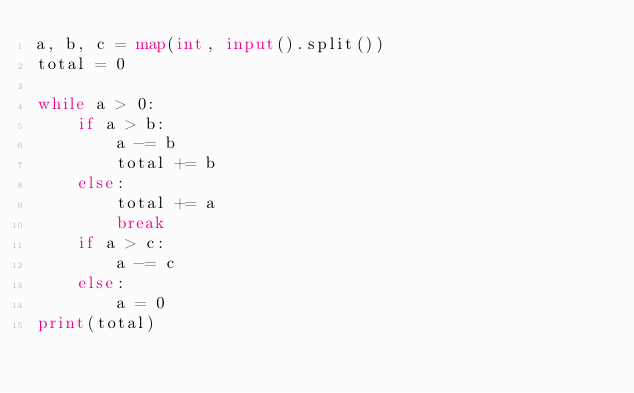<code> <loc_0><loc_0><loc_500><loc_500><_Python_>a, b, c = map(int, input().split())
total = 0

while a > 0:
    if a > b:
        a -= b
        total += b
    else:
        total += a
        break
    if a > c:
        a -= c
    else:
        a = 0
print(total)</code> 